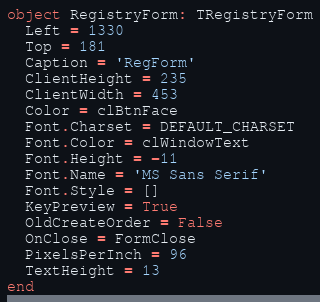<code> <loc_0><loc_0><loc_500><loc_500><_Pascal_>object RegistryForm: TRegistryForm
  Left = 1330
  Top = 181
  Caption = 'RegForm'
  ClientHeight = 235
  ClientWidth = 453
  Color = clBtnFace
  Font.Charset = DEFAULT_CHARSET
  Font.Color = clWindowText
  Font.Height = -11
  Font.Name = 'MS Sans Serif'
  Font.Style = []
  KeyPreview = True
  OldCreateOrder = False
  OnClose = FormClose
  PixelsPerInch = 96
  TextHeight = 13
end
</code> 